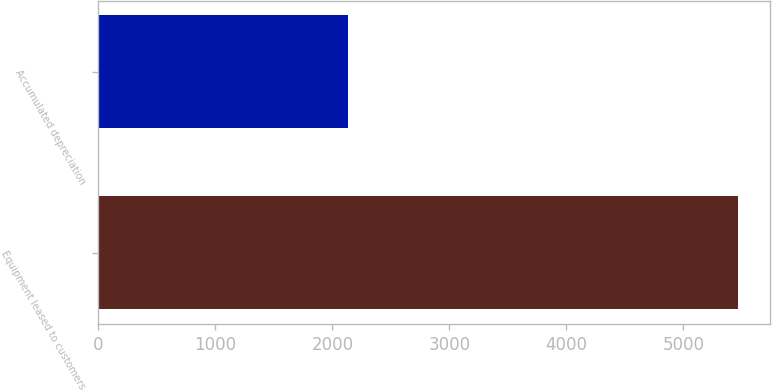<chart> <loc_0><loc_0><loc_500><loc_500><bar_chart><fcel>Equipment leased to customers<fcel>Accumulated depreciation<nl><fcel>5467<fcel>2134<nl></chart> 